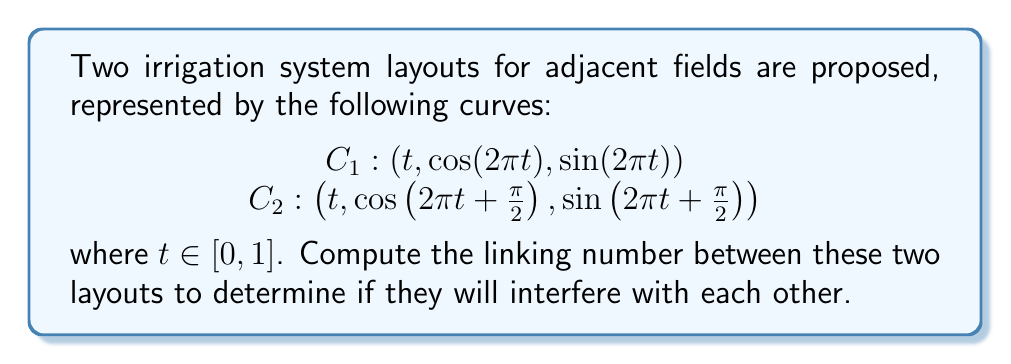Help me with this question. To compute the linking number between two curves, we can use the Gauss linking integral:

$$Lk(C_1, C_2) = \frac{1}{4\pi} \int_{C_1} \int_{C_2} \frac{(\dot{r_1} \times \dot{r_2}) \cdot (r_1 - r_2)}{|r_1 - r_2|^3} dt_1 dt_2$$

Where $r_1$ and $r_2$ are position vectors on $C_1$ and $C_2$ respectively, and $\dot{r_1}$ and $\dot{r_2}$ are their derivatives.

Step 1: Calculate $\dot{r_1}$ and $\dot{r_2}$
$\dot{r_1} = (1, -2\pi\sin(2\pi t), 2\pi\cos(2\pi t))$
$\dot{r_2} = (1, -2\pi\sin(2\pi t + \frac{\pi}{2}), 2\pi\cos(2\pi t + \frac{\pi}{2}))$

Step 2: Calculate $r_1 - r_2$
$r_1 - r_2 = (0, \cos(2\pi t) - \cos(2\pi t + \frac{\pi}{2}), \sin(2\pi t) - \sin(2\pi t + \frac{\pi}{2}))$

Step 3: Calculate $\dot{r_1} \times \dot{r_2}$
$\dot{r_1} \times \dot{r_2} = (4\pi^2\sin(\frac{\pi}{2}), 2\pi\cos(2\pi t + \frac{\pi}{2}), 2\pi\sin(2\pi t + \frac{\pi}{2}))$

Step 4: Calculate $(\dot{r_1} \times \dot{r_2}) \cdot (r_1 - r_2)$
This gives us a constant value of $4\pi^2$.

Step 5: Calculate $|r_1 - r_2|^3$
$|r_1 - r_2|^3 = (\sin^2(\frac{\pi}{2}))^{3/2} = 1$

Step 6: Integrate
Due to the constant numerator and denominator, the integral simplifies to:

$$Lk(C_1, C_2) = \frac{1}{4\pi} \cdot 4\pi^2 \cdot 1 \cdot 1 = \pi$$

The linking number must be an integer, so we round to the nearest integer.
Answer: $Lk(C_1, C_2) = 1$ 